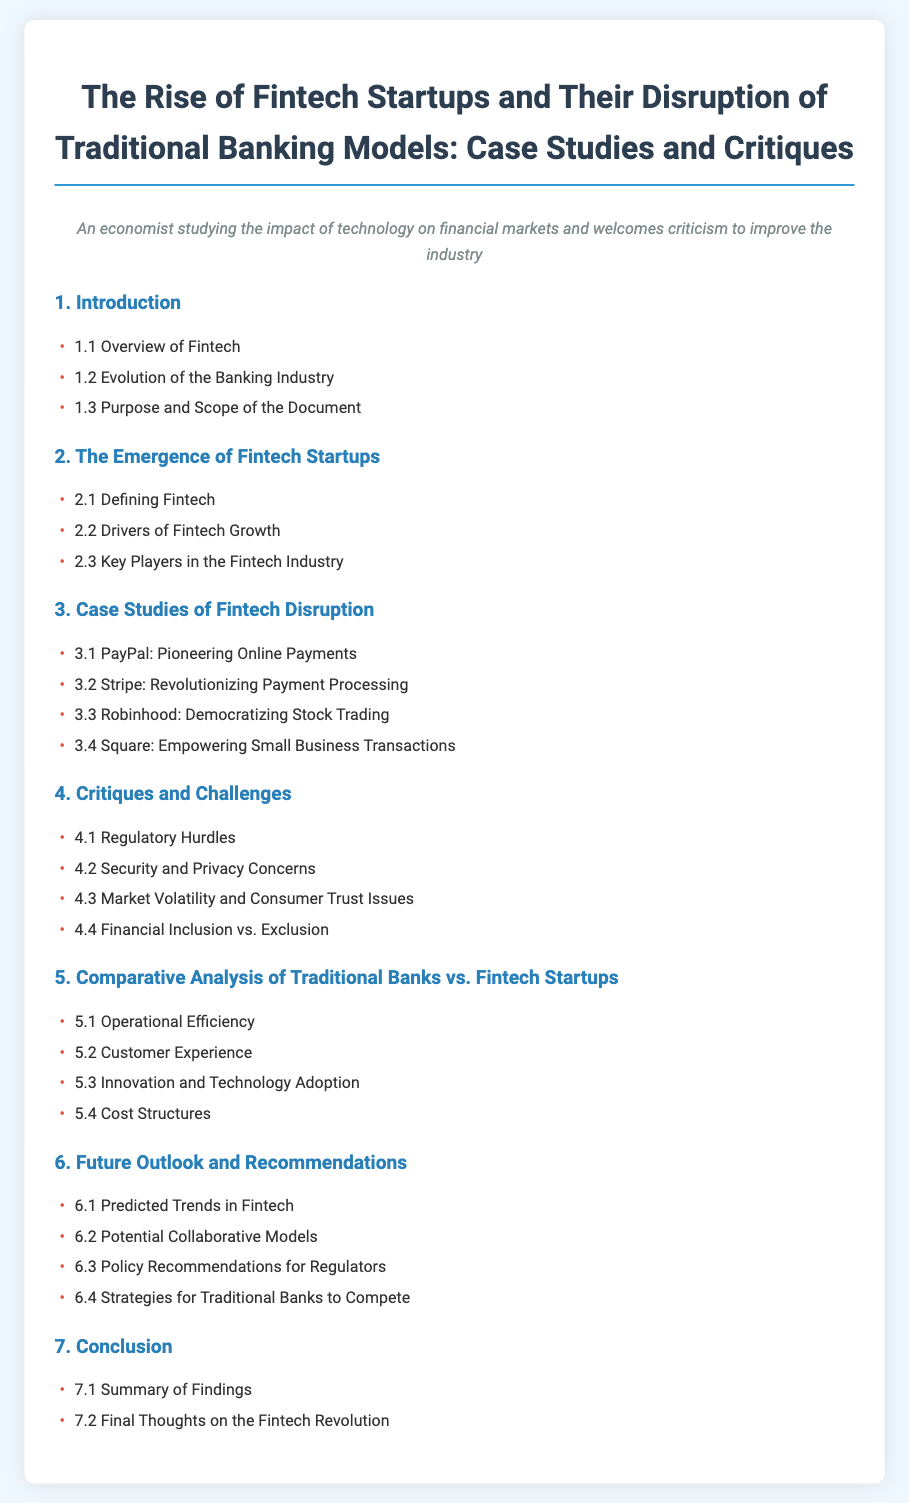what is the title of the document? The title is explicitly stated at the beginning of the document, summarizing the main focus.
Answer: The Rise of Fintech Startups and Their Disruption of Traditional Banking Models: Case Studies and Critiques how many chapters are in the document? The number of chapters is counted from the table of contents.
Answer: 7 which section discusses regulatory challenges? This section is clearly mentioned in the table of contents under critiques.
Answer: Regulatory Hurdles what is the first case study mentioned? The first case study appears as the initial item in the case studies chapter.
Answer: PayPal: Pioneering Online Payments what chapter covers the future outlook? This question refers to the chapter that provides predictions and recommendations.
Answer: 6. Future Outlook and Recommendations what section is about the customer experience in fintech? The specific section regarding customer experience in the comparative chapter is identifiable.
Answer: Customer Experience which fintech startup is associated with democratizing stock trading? This identifies a specific company highlighted in the case studies section.
Answer: Robinhood: Democratizing Stock Trading what is one of the predicted trends in fintech? This refers to the section that includes potential future developments.
Answer: Predicted Trends in Fintech 